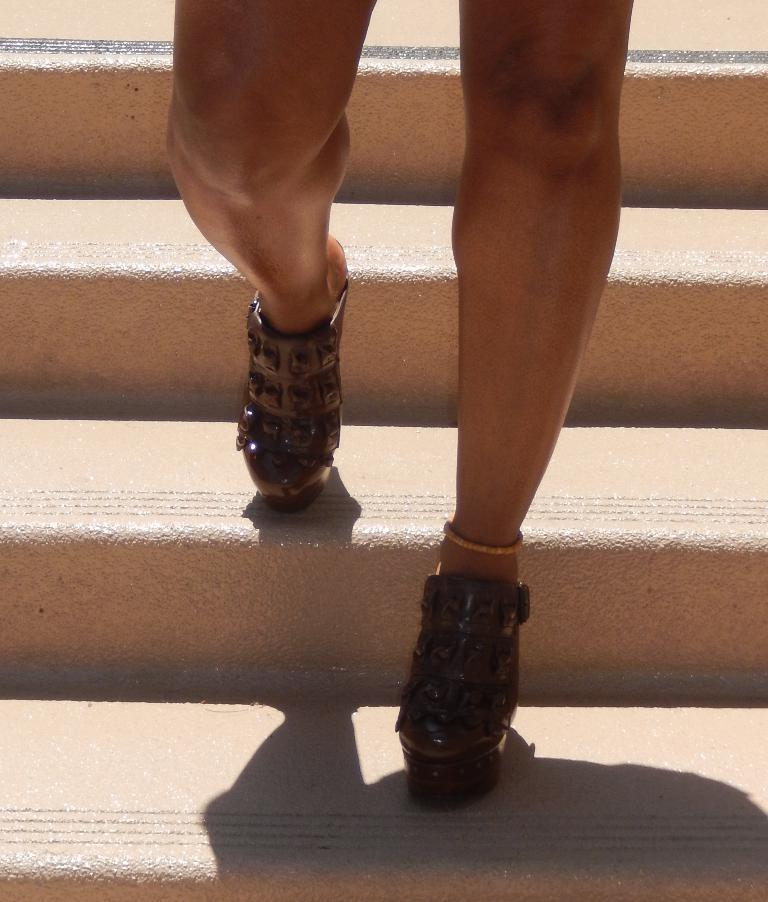What is the main subject of the image? There is a person in the image. Where is the person located in the image? The person is standing on the stairs. What type of footwear is the person wearing? The person is wearing boots. What type of toad can be seen hopping on the stairs in the image? There is no toad present in the image; it only features a person standing on the stairs. How does the person's hearing affect their ability to navigate the stairs in the image? The person's hearing is not mentioned in the image, so it cannot be determined how it affects their ability to navigate the stairs. 